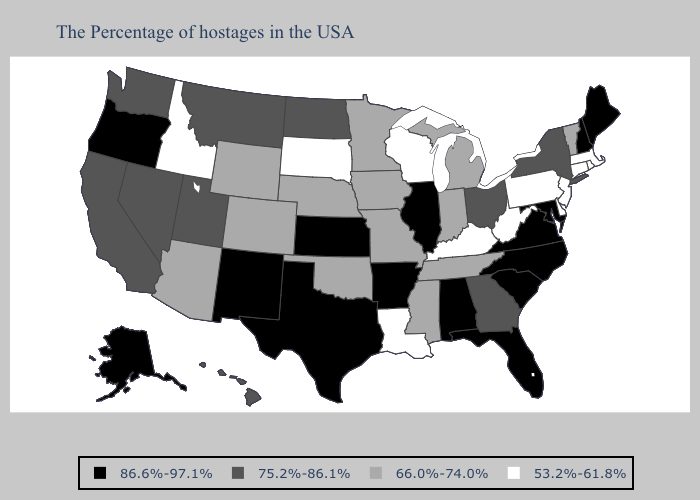What is the value of Kansas?
Be succinct. 86.6%-97.1%. What is the lowest value in the USA?
Keep it brief. 53.2%-61.8%. Does Vermont have a lower value than Missouri?
Quick response, please. No. Name the states that have a value in the range 66.0%-74.0%?
Short answer required. Vermont, Michigan, Indiana, Tennessee, Mississippi, Missouri, Minnesota, Iowa, Nebraska, Oklahoma, Wyoming, Colorado, Arizona. Among the states that border Indiana , does Michigan have the highest value?
Be succinct. No. Does Louisiana have the lowest value in the USA?
Concise answer only. Yes. Does Arkansas have the highest value in the USA?
Keep it brief. Yes. Does the first symbol in the legend represent the smallest category?
Give a very brief answer. No. Does Connecticut have a higher value than Alabama?
Write a very short answer. No. What is the value of Washington?
Answer briefly. 75.2%-86.1%. What is the value of Colorado?
Keep it brief. 66.0%-74.0%. Does the first symbol in the legend represent the smallest category?
Be succinct. No. Does Texas have the same value as Maryland?
Quick response, please. Yes. Name the states that have a value in the range 53.2%-61.8%?
Write a very short answer. Massachusetts, Rhode Island, Connecticut, New Jersey, Delaware, Pennsylvania, West Virginia, Kentucky, Wisconsin, Louisiana, South Dakota, Idaho. Name the states that have a value in the range 53.2%-61.8%?
Keep it brief. Massachusetts, Rhode Island, Connecticut, New Jersey, Delaware, Pennsylvania, West Virginia, Kentucky, Wisconsin, Louisiana, South Dakota, Idaho. 